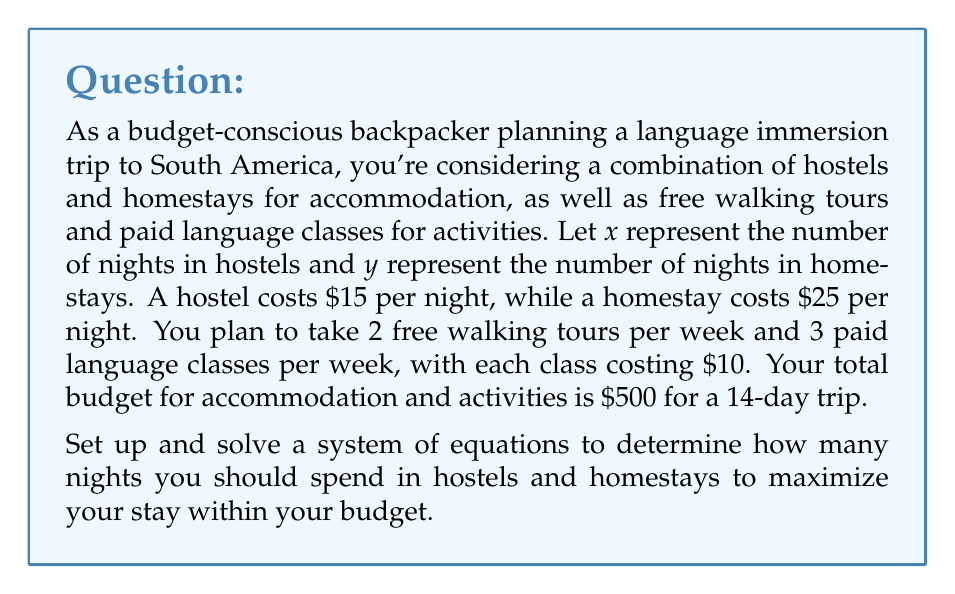Teach me how to tackle this problem. Let's approach this problem step by step:

1) First, let's set up our equations:

   Equation 1 (total nights): $x + y = 14$
   
   Equation 2 (budget constraint): $15x + 25y + 10(3 \cdot 2) + 0(2 \cdot 2) = 500$

2) Simplify Equation 2:
   $15x + 25y + 60 = 500$
   $15x + 25y = 440$

3) Now we have a system of two equations:
   $$\begin{cases}
   x + y = 14 \\
   15x + 25y = 440
   \end{cases}$$

4) Let's solve this system by substitution. From the first equation:
   $x = 14 - y$

5) Substitute this into the second equation:
   $15(14 - y) + 25y = 440$
   $210 - 15y + 25y = 440$
   $210 + 10y = 440$

6) Solve for y:
   $10y = 230$
   $y = 23$

7) Now substitute this value of y back into the equation from step 4:
   $x = 14 - 23 = -9$

8) Since we can't have a negative number of nights, this solution is not feasible within our constraints. This means we should maximize one variable.

9) Let's try maximizing homestays (y) within our budget:
   If $y = 14$ (all nights in homestays):
   $25 \cdot 14 + 60 = 410$ (for accommodation and classes)
   This is within our budget of $500.

10) Therefore, the most budget-friendly option that maximizes our stay is to spend all 14 nights in homestays.
Answer: The most budget-friendly combination is to spend all 14 nights in homestays ($y = 14$, $x = 0$). This will cost $410 for accommodation and classes, leaving $90 for other expenses while staying within the $500 budget. 